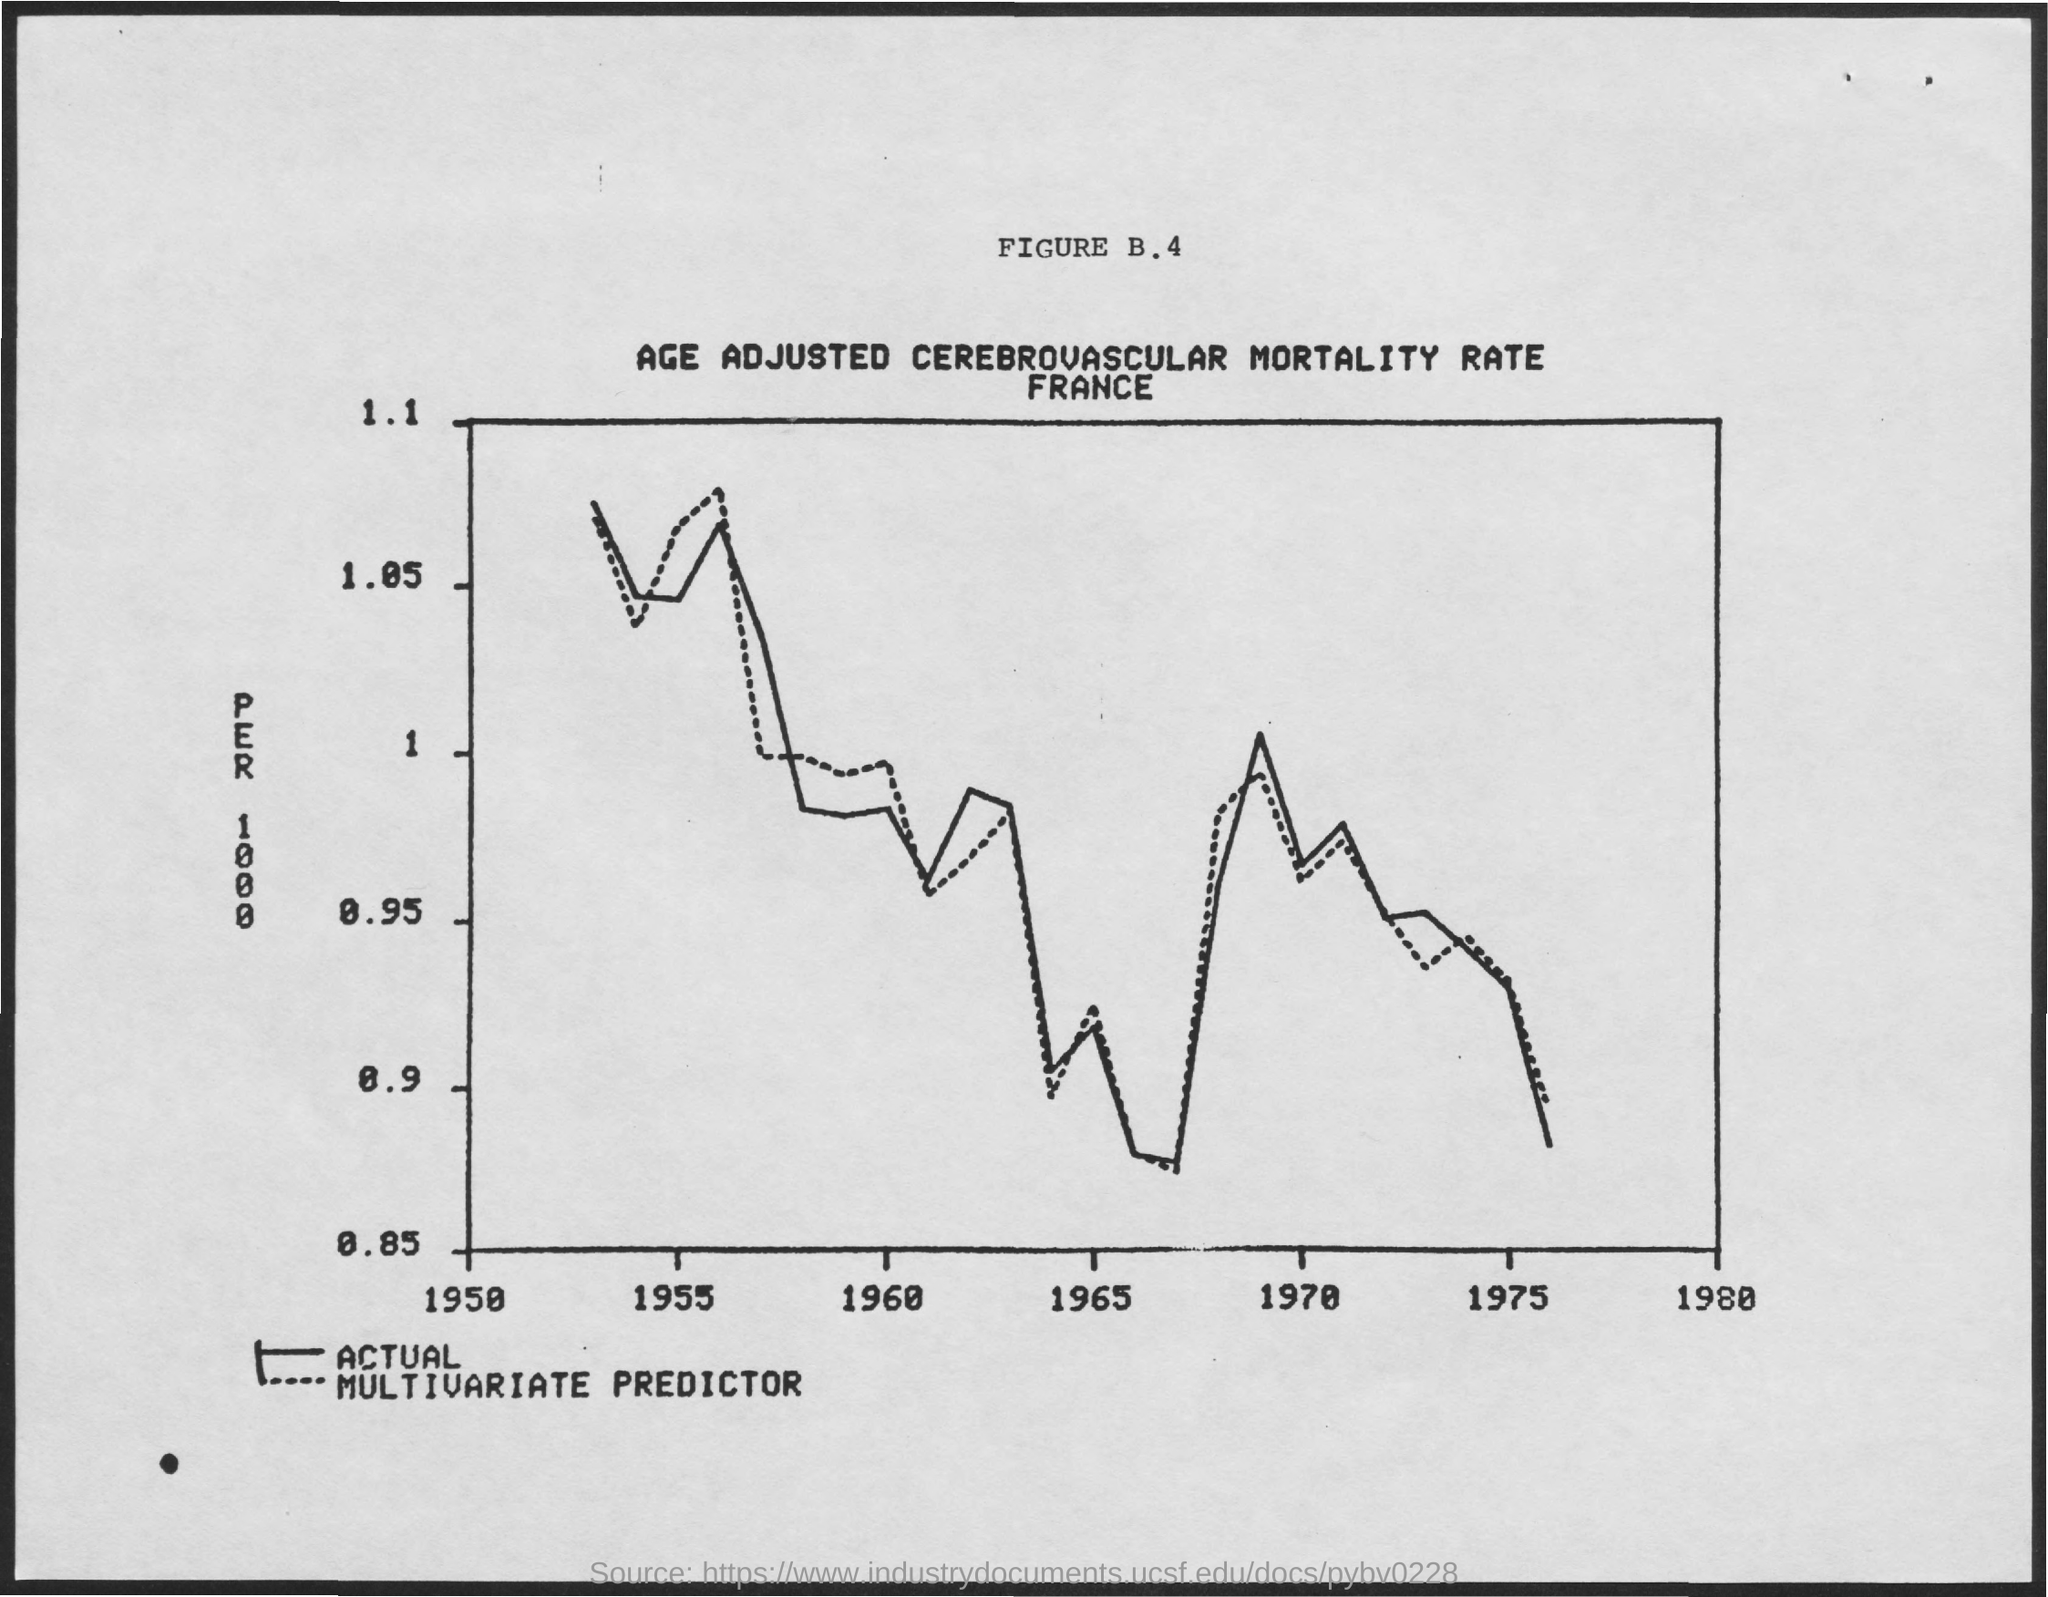What is the figure number mentioned ?
Your answer should be very brief. B.4. What is the title mentioned ?
Provide a short and direct response. Age adjusted cerebrovascular mortality rate. 